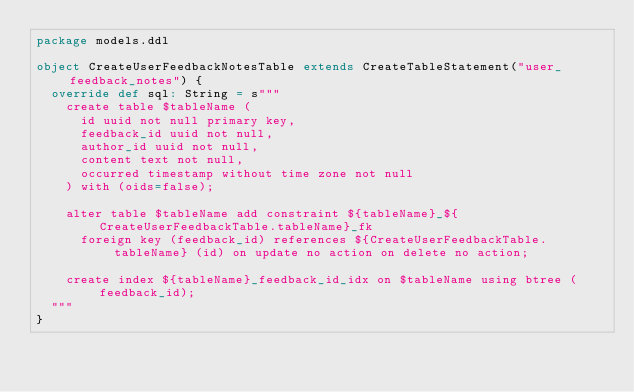Convert code to text. <code><loc_0><loc_0><loc_500><loc_500><_Scala_>package models.ddl

object CreateUserFeedbackNotesTable extends CreateTableStatement("user_feedback_notes") {
  override def sql: String = s"""
    create table $tableName (
      id uuid not null primary key,
      feedback_id uuid not null,
      author_id uuid not null,
      content text not null,
      occurred timestamp without time zone not null
    ) with (oids=false);

    alter table $tableName add constraint ${tableName}_${CreateUserFeedbackTable.tableName}_fk
      foreign key (feedback_id) references ${CreateUserFeedbackTable.tableName} (id) on update no action on delete no action;

    create index ${tableName}_feedback_id_idx on $tableName using btree (feedback_id);
  """
}
</code> 